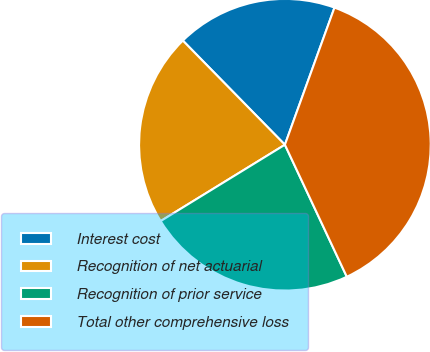<chart> <loc_0><loc_0><loc_500><loc_500><pie_chart><fcel>Interest cost<fcel>Recognition of net actuarial<fcel>Recognition of prior service<fcel>Total other comprehensive loss<nl><fcel>17.86%<fcel>21.43%<fcel>23.21%<fcel>37.5%<nl></chart> 